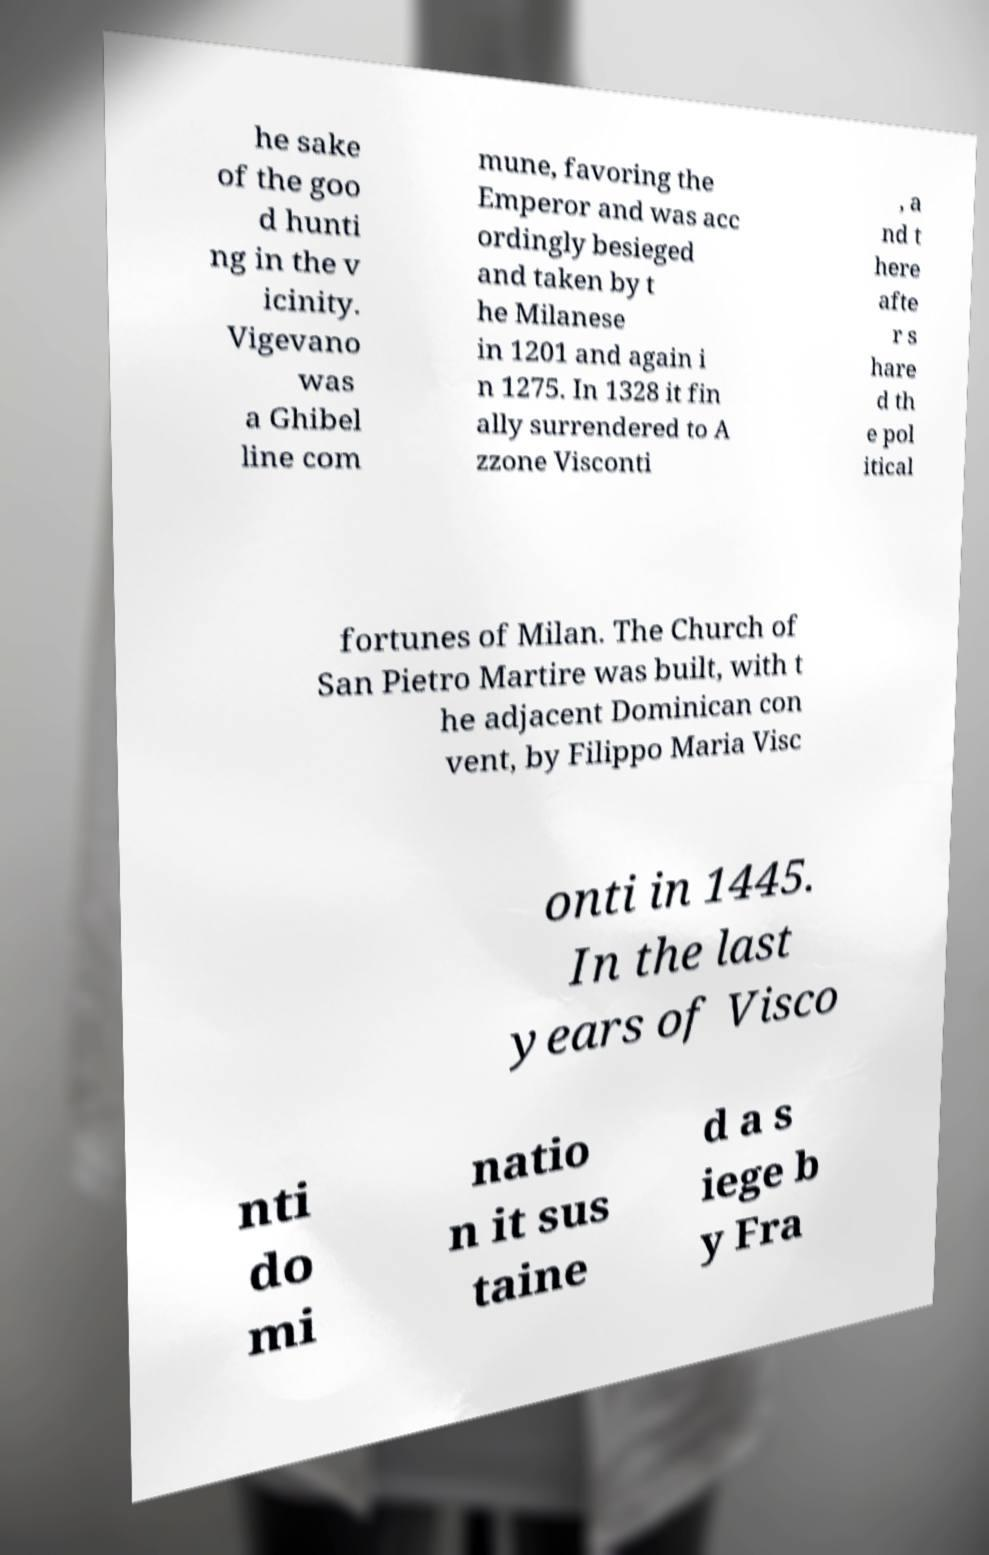Please read and relay the text visible in this image. What does it say? he sake of the goo d hunti ng in the v icinity. Vigevano was a Ghibel line com mune, favoring the Emperor and was acc ordingly besieged and taken by t he Milanese in 1201 and again i n 1275. In 1328 it fin ally surrendered to A zzone Visconti , a nd t here afte r s hare d th e pol itical fortunes of Milan. The Church of San Pietro Martire was built, with t he adjacent Dominican con vent, by Filippo Maria Visc onti in 1445. In the last years of Visco nti do mi natio n it sus taine d a s iege b y Fra 